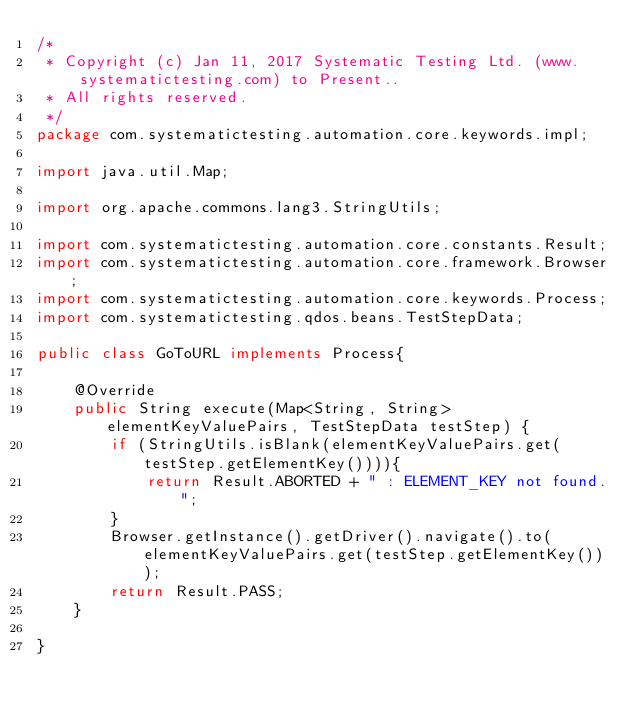Convert code to text. <code><loc_0><loc_0><loc_500><loc_500><_Java_>/*
 * Copyright (c) Jan 11, 2017 Systematic Testing Ltd. (www.systematictesting.com) to Present..
 * All rights reserved. 
 */
package com.systematictesting.automation.core.keywords.impl;

import java.util.Map;

import org.apache.commons.lang3.StringUtils;

import com.systematictesting.automation.core.constants.Result;
import com.systematictesting.automation.core.framework.Browser;
import com.systematictesting.automation.core.keywords.Process;
import com.systematictesting.qdos.beans.TestStepData;

public class GoToURL implements Process{

	@Override
	public String execute(Map<String, String> elementKeyValuePairs, TestStepData testStep) {
		if (StringUtils.isBlank(elementKeyValuePairs.get(testStep.getElementKey()))){
			return Result.ABORTED + " : ELEMENT_KEY not found.";
		}
		Browser.getInstance().getDriver().navigate().to(elementKeyValuePairs.get(testStep.getElementKey()));
		return Result.PASS;
	}

}
</code> 